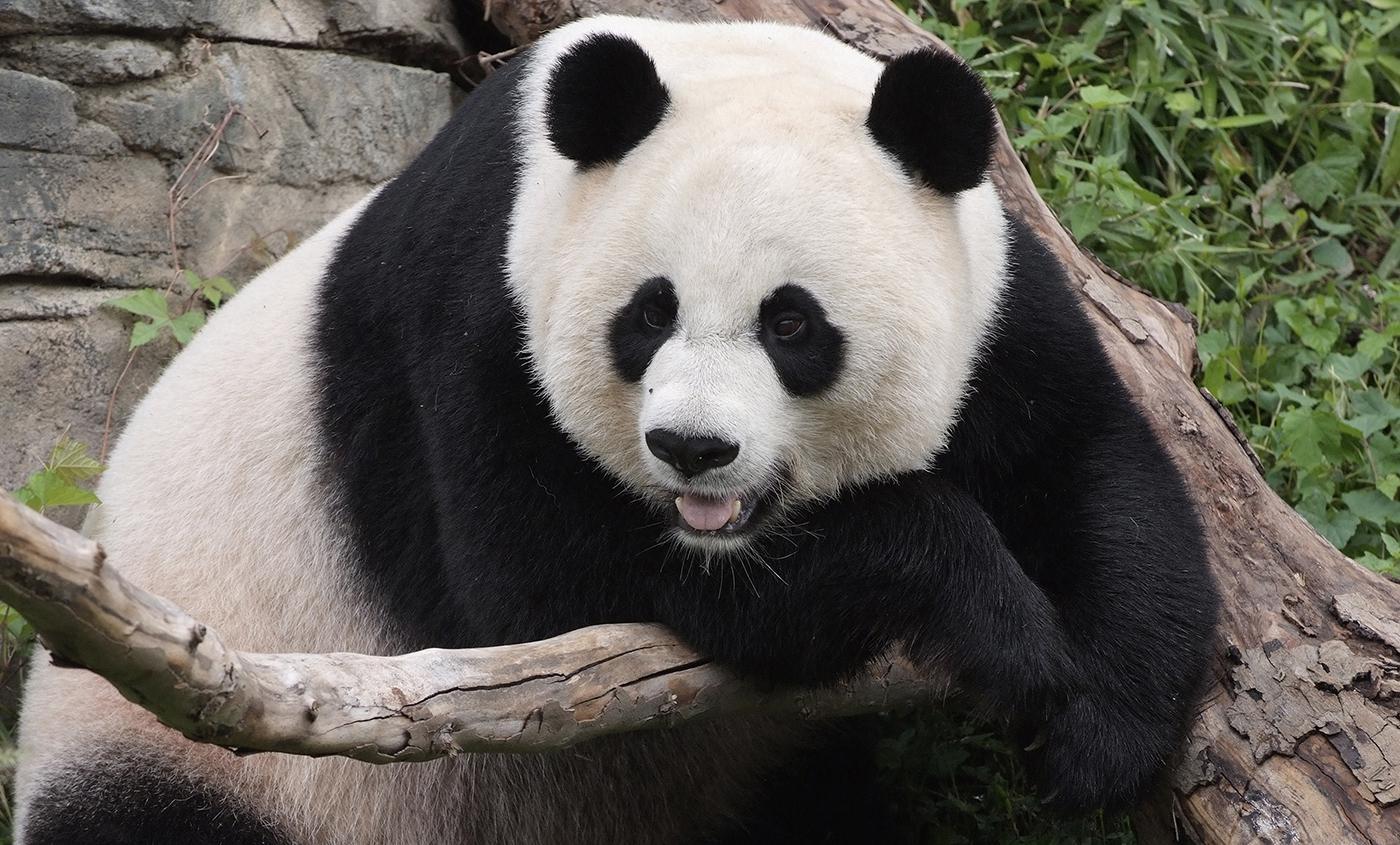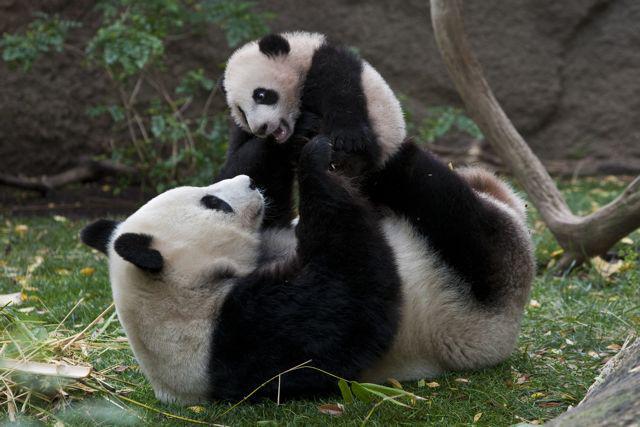The first image is the image on the left, the second image is the image on the right. Considering the images on both sides, is "The panda is sitting on top of a tree branch in the right image." valid? Answer yes or no. No. 